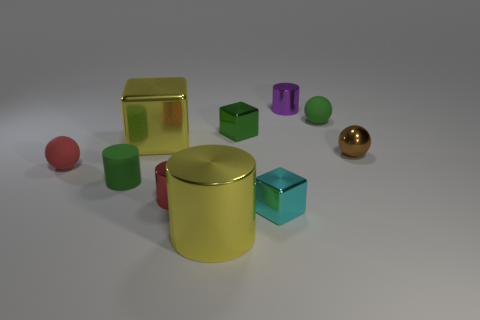What shape is the object that is the same color as the big cube?
Ensure brevity in your answer.  Cylinder. What material is the block that is to the right of the big yellow metallic cylinder and behind the cyan metal object?
Your answer should be very brief. Metal. How many small objects are either purple objects or green blocks?
Make the answer very short. 2. What size is the green block?
Your answer should be compact. Small. What is the shape of the brown metallic object?
Your response must be concise. Sphere. Are there any other things that have the same shape as the red rubber object?
Provide a succinct answer. Yes. Are there fewer green blocks that are in front of the big yellow metallic cylinder than cubes?
Provide a succinct answer. Yes. Does the metallic thing on the right side of the purple shiny cylinder have the same color as the big shiny cylinder?
Offer a very short reply. No. How many matte things are large red objects or large things?
Provide a short and direct response. 0. Is there any other thing that is the same size as the red rubber ball?
Your answer should be compact. Yes. 